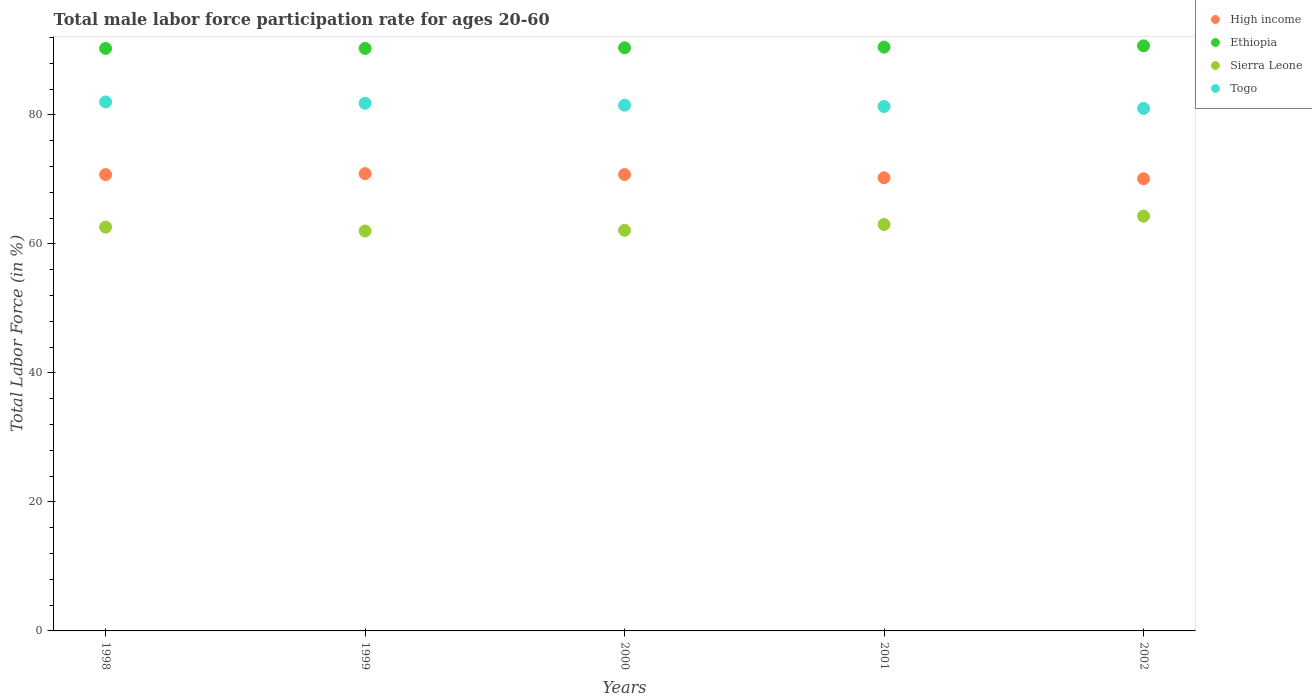How many different coloured dotlines are there?
Make the answer very short. 4. Is the number of dotlines equal to the number of legend labels?
Provide a succinct answer. Yes. What is the male labor force participation rate in Ethiopia in 1999?
Provide a short and direct response. 90.3. Across all years, what is the maximum male labor force participation rate in Sierra Leone?
Give a very brief answer. 64.3. Across all years, what is the minimum male labor force participation rate in Ethiopia?
Offer a terse response. 90.3. In which year was the male labor force participation rate in High income minimum?
Your response must be concise. 2002. What is the total male labor force participation rate in Sierra Leone in the graph?
Your answer should be very brief. 314. What is the difference between the male labor force participation rate in Ethiopia in 1999 and that in 2000?
Make the answer very short. -0.1. What is the difference between the male labor force participation rate in Sierra Leone in 1998 and the male labor force participation rate in High income in 2001?
Give a very brief answer. -7.64. What is the average male labor force participation rate in Sierra Leone per year?
Provide a short and direct response. 62.8. In the year 1999, what is the difference between the male labor force participation rate in Ethiopia and male labor force participation rate in Togo?
Keep it short and to the point. 8.5. In how many years, is the male labor force participation rate in Togo greater than 48 %?
Provide a short and direct response. 5. What is the ratio of the male labor force participation rate in Togo in 1999 to that in 2001?
Provide a succinct answer. 1.01. Is the male labor force participation rate in Togo in 1999 less than that in 2000?
Ensure brevity in your answer.  No. What is the difference between the highest and the second highest male labor force participation rate in High income?
Your answer should be very brief. 0.14. In how many years, is the male labor force participation rate in High income greater than the average male labor force participation rate in High income taken over all years?
Give a very brief answer. 3. Does the male labor force participation rate in Ethiopia monotonically increase over the years?
Ensure brevity in your answer.  No. Is the male labor force participation rate in Sierra Leone strictly less than the male labor force participation rate in Ethiopia over the years?
Offer a very short reply. Yes. How many dotlines are there?
Your answer should be very brief. 4. Does the graph contain any zero values?
Give a very brief answer. No. Does the graph contain grids?
Your answer should be very brief. No. How many legend labels are there?
Offer a terse response. 4. How are the legend labels stacked?
Offer a terse response. Vertical. What is the title of the graph?
Offer a very short reply. Total male labor force participation rate for ages 20-60. What is the label or title of the X-axis?
Ensure brevity in your answer.  Years. What is the label or title of the Y-axis?
Keep it short and to the point. Total Labor Force (in %). What is the Total Labor Force (in %) of High income in 1998?
Your response must be concise. 70.74. What is the Total Labor Force (in %) of Ethiopia in 1998?
Your response must be concise. 90.3. What is the Total Labor Force (in %) of Sierra Leone in 1998?
Provide a succinct answer. 62.6. What is the Total Labor Force (in %) of High income in 1999?
Make the answer very short. 70.88. What is the Total Labor Force (in %) of Ethiopia in 1999?
Ensure brevity in your answer.  90.3. What is the Total Labor Force (in %) of Sierra Leone in 1999?
Offer a terse response. 62. What is the Total Labor Force (in %) in Togo in 1999?
Ensure brevity in your answer.  81.8. What is the Total Labor Force (in %) in High income in 2000?
Your response must be concise. 70.75. What is the Total Labor Force (in %) in Ethiopia in 2000?
Keep it short and to the point. 90.4. What is the Total Labor Force (in %) in Sierra Leone in 2000?
Offer a terse response. 62.1. What is the Total Labor Force (in %) of Togo in 2000?
Provide a succinct answer. 81.5. What is the Total Labor Force (in %) in High income in 2001?
Keep it short and to the point. 70.24. What is the Total Labor Force (in %) in Ethiopia in 2001?
Make the answer very short. 90.5. What is the Total Labor Force (in %) of Togo in 2001?
Your answer should be very brief. 81.3. What is the Total Labor Force (in %) of High income in 2002?
Your response must be concise. 70.09. What is the Total Labor Force (in %) of Ethiopia in 2002?
Your answer should be compact. 90.7. What is the Total Labor Force (in %) of Sierra Leone in 2002?
Provide a succinct answer. 64.3. Across all years, what is the maximum Total Labor Force (in %) in High income?
Ensure brevity in your answer.  70.88. Across all years, what is the maximum Total Labor Force (in %) of Ethiopia?
Offer a very short reply. 90.7. Across all years, what is the maximum Total Labor Force (in %) of Sierra Leone?
Your answer should be compact. 64.3. Across all years, what is the maximum Total Labor Force (in %) in Togo?
Your answer should be compact. 82. Across all years, what is the minimum Total Labor Force (in %) in High income?
Provide a succinct answer. 70.09. Across all years, what is the minimum Total Labor Force (in %) in Ethiopia?
Provide a succinct answer. 90.3. Across all years, what is the minimum Total Labor Force (in %) in Sierra Leone?
Make the answer very short. 62. Across all years, what is the minimum Total Labor Force (in %) of Togo?
Ensure brevity in your answer.  81. What is the total Total Labor Force (in %) of High income in the graph?
Ensure brevity in your answer.  352.7. What is the total Total Labor Force (in %) in Ethiopia in the graph?
Your response must be concise. 452.2. What is the total Total Labor Force (in %) in Sierra Leone in the graph?
Give a very brief answer. 314. What is the total Total Labor Force (in %) in Togo in the graph?
Keep it short and to the point. 407.6. What is the difference between the Total Labor Force (in %) of High income in 1998 and that in 1999?
Ensure brevity in your answer.  -0.14. What is the difference between the Total Labor Force (in %) of Ethiopia in 1998 and that in 1999?
Give a very brief answer. 0. What is the difference between the Total Labor Force (in %) in Sierra Leone in 1998 and that in 1999?
Give a very brief answer. 0.6. What is the difference between the Total Labor Force (in %) in High income in 1998 and that in 2000?
Your response must be concise. -0.01. What is the difference between the Total Labor Force (in %) of Sierra Leone in 1998 and that in 2000?
Ensure brevity in your answer.  0.5. What is the difference between the Total Labor Force (in %) of Togo in 1998 and that in 2000?
Give a very brief answer. 0.5. What is the difference between the Total Labor Force (in %) of High income in 1998 and that in 2001?
Your response must be concise. 0.49. What is the difference between the Total Labor Force (in %) of Ethiopia in 1998 and that in 2001?
Offer a terse response. -0.2. What is the difference between the Total Labor Force (in %) in Togo in 1998 and that in 2001?
Keep it short and to the point. 0.7. What is the difference between the Total Labor Force (in %) of High income in 1998 and that in 2002?
Offer a very short reply. 0.65. What is the difference between the Total Labor Force (in %) of Sierra Leone in 1998 and that in 2002?
Provide a short and direct response. -1.7. What is the difference between the Total Labor Force (in %) of High income in 1999 and that in 2000?
Make the answer very short. 0.14. What is the difference between the Total Labor Force (in %) in Sierra Leone in 1999 and that in 2000?
Your answer should be very brief. -0.1. What is the difference between the Total Labor Force (in %) of Togo in 1999 and that in 2000?
Offer a terse response. 0.3. What is the difference between the Total Labor Force (in %) of High income in 1999 and that in 2001?
Give a very brief answer. 0.64. What is the difference between the Total Labor Force (in %) of Sierra Leone in 1999 and that in 2001?
Make the answer very short. -1. What is the difference between the Total Labor Force (in %) in High income in 1999 and that in 2002?
Offer a very short reply. 0.79. What is the difference between the Total Labor Force (in %) in Ethiopia in 1999 and that in 2002?
Give a very brief answer. -0.4. What is the difference between the Total Labor Force (in %) of Sierra Leone in 1999 and that in 2002?
Keep it short and to the point. -2.3. What is the difference between the Total Labor Force (in %) in Togo in 1999 and that in 2002?
Make the answer very short. 0.8. What is the difference between the Total Labor Force (in %) in High income in 2000 and that in 2001?
Offer a very short reply. 0.5. What is the difference between the Total Labor Force (in %) of Sierra Leone in 2000 and that in 2001?
Give a very brief answer. -0.9. What is the difference between the Total Labor Force (in %) of High income in 2000 and that in 2002?
Your answer should be compact. 0.66. What is the difference between the Total Labor Force (in %) of Ethiopia in 2000 and that in 2002?
Your answer should be very brief. -0.3. What is the difference between the Total Labor Force (in %) in Sierra Leone in 2000 and that in 2002?
Keep it short and to the point. -2.2. What is the difference between the Total Labor Force (in %) of Togo in 2000 and that in 2002?
Your answer should be very brief. 0.5. What is the difference between the Total Labor Force (in %) in High income in 2001 and that in 2002?
Your response must be concise. 0.15. What is the difference between the Total Labor Force (in %) in High income in 1998 and the Total Labor Force (in %) in Ethiopia in 1999?
Provide a short and direct response. -19.56. What is the difference between the Total Labor Force (in %) in High income in 1998 and the Total Labor Force (in %) in Sierra Leone in 1999?
Give a very brief answer. 8.74. What is the difference between the Total Labor Force (in %) of High income in 1998 and the Total Labor Force (in %) of Togo in 1999?
Offer a terse response. -11.06. What is the difference between the Total Labor Force (in %) of Ethiopia in 1998 and the Total Labor Force (in %) of Sierra Leone in 1999?
Give a very brief answer. 28.3. What is the difference between the Total Labor Force (in %) in Ethiopia in 1998 and the Total Labor Force (in %) in Togo in 1999?
Your response must be concise. 8.5. What is the difference between the Total Labor Force (in %) in Sierra Leone in 1998 and the Total Labor Force (in %) in Togo in 1999?
Give a very brief answer. -19.2. What is the difference between the Total Labor Force (in %) in High income in 1998 and the Total Labor Force (in %) in Ethiopia in 2000?
Offer a very short reply. -19.66. What is the difference between the Total Labor Force (in %) in High income in 1998 and the Total Labor Force (in %) in Sierra Leone in 2000?
Provide a succinct answer. 8.64. What is the difference between the Total Labor Force (in %) in High income in 1998 and the Total Labor Force (in %) in Togo in 2000?
Make the answer very short. -10.76. What is the difference between the Total Labor Force (in %) of Ethiopia in 1998 and the Total Labor Force (in %) of Sierra Leone in 2000?
Make the answer very short. 28.2. What is the difference between the Total Labor Force (in %) of Sierra Leone in 1998 and the Total Labor Force (in %) of Togo in 2000?
Your answer should be compact. -18.9. What is the difference between the Total Labor Force (in %) in High income in 1998 and the Total Labor Force (in %) in Ethiopia in 2001?
Offer a terse response. -19.76. What is the difference between the Total Labor Force (in %) of High income in 1998 and the Total Labor Force (in %) of Sierra Leone in 2001?
Make the answer very short. 7.74. What is the difference between the Total Labor Force (in %) in High income in 1998 and the Total Labor Force (in %) in Togo in 2001?
Provide a succinct answer. -10.56. What is the difference between the Total Labor Force (in %) of Ethiopia in 1998 and the Total Labor Force (in %) of Sierra Leone in 2001?
Offer a very short reply. 27.3. What is the difference between the Total Labor Force (in %) of Ethiopia in 1998 and the Total Labor Force (in %) of Togo in 2001?
Make the answer very short. 9. What is the difference between the Total Labor Force (in %) in Sierra Leone in 1998 and the Total Labor Force (in %) in Togo in 2001?
Your response must be concise. -18.7. What is the difference between the Total Labor Force (in %) in High income in 1998 and the Total Labor Force (in %) in Ethiopia in 2002?
Provide a succinct answer. -19.96. What is the difference between the Total Labor Force (in %) of High income in 1998 and the Total Labor Force (in %) of Sierra Leone in 2002?
Provide a succinct answer. 6.44. What is the difference between the Total Labor Force (in %) of High income in 1998 and the Total Labor Force (in %) of Togo in 2002?
Give a very brief answer. -10.26. What is the difference between the Total Labor Force (in %) in Ethiopia in 1998 and the Total Labor Force (in %) in Togo in 2002?
Give a very brief answer. 9.3. What is the difference between the Total Labor Force (in %) in Sierra Leone in 1998 and the Total Labor Force (in %) in Togo in 2002?
Offer a terse response. -18.4. What is the difference between the Total Labor Force (in %) in High income in 1999 and the Total Labor Force (in %) in Ethiopia in 2000?
Ensure brevity in your answer.  -19.52. What is the difference between the Total Labor Force (in %) of High income in 1999 and the Total Labor Force (in %) of Sierra Leone in 2000?
Provide a succinct answer. 8.78. What is the difference between the Total Labor Force (in %) in High income in 1999 and the Total Labor Force (in %) in Togo in 2000?
Keep it short and to the point. -10.62. What is the difference between the Total Labor Force (in %) of Ethiopia in 1999 and the Total Labor Force (in %) of Sierra Leone in 2000?
Provide a short and direct response. 28.2. What is the difference between the Total Labor Force (in %) of Sierra Leone in 1999 and the Total Labor Force (in %) of Togo in 2000?
Provide a short and direct response. -19.5. What is the difference between the Total Labor Force (in %) of High income in 1999 and the Total Labor Force (in %) of Ethiopia in 2001?
Provide a short and direct response. -19.62. What is the difference between the Total Labor Force (in %) of High income in 1999 and the Total Labor Force (in %) of Sierra Leone in 2001?
Your answer should be compact. 7.88. What is the difference between the Total Labor Force (in %) in High income in 1999 and the Total Labor Force (in %) in Togo in 2001?
Offer a very short reply. -10.42. What is the difference between the Total Labor Force (in %) of Ethiopia in 1999 and the Total Labor Force (in %) of Sierra Leone in 2001?
Give a very brief answer. 27.3. What is the difference between the Total Labor Force (in %) of Ethiopia in 1999 and the Total Labor Force (in %) of Togo in 2001?
Provide a succinct answer. 9. What is the difference between the Total Labor Force (in %) in Sierra Leone in 1999 and the Total Labor Force (in %) in Togo in 2001?
Offer a terse response. -19.3. What is the difference between the Total Labor Force (in %) of High income in 1999 and the Total Labor Force (in %) of Ethiopia in 2002?
Your answer should be very brief. -19.82. What is the difference between the Total Labor Force (in %) of High income in 1999 and the Total Labor Force (in %) of Sierra Leone in 2002?
Offer a terse response. 6.58. What is the difference between the Total Labor Force (in %) of High income in 1999 and the Total Labor Force (in %) of Togo in 2002?
Make the answer very short. -10.12. What is the difference between the Total Labor Force (in %) of Ethiopia in 1999 and the Total Labor Force (in %) of Sierra Leone in 2002?
Give a very brief answer. 26. What is the difference between the Total Labor Force (in %) of Ethiopia in 1999 and the Total Labor Force (in %) of Togo in 2002?
Your answer should be compact. 9.3. What is the difference between the Total Labor Force (in %) of Sierra Leone in 1999 and the Total Labor Force (in %) of Togo in 2002?
Give a very brief answer. -19. What is the difference between the Total Labor Force (in %) of High income in 2000 and the Total Labor Force (in %) of Ethiopia in 2001?
Your answer should be very brief. -19.75. What is the difference between the Total Labor Force (in %) of High income in 2000 and the Total Labor Force (in %) of Sierra Leone in 2001?
Ensure brevity in your answer.  7.75. What is the difference between the Total Labor Force (in %) of High income in 2000 and the Total Labor Force (in %) of Togo in 2001?
Keep it short and to the point. -10.55. What is the difference between the Total Labor Force (in %) of Ethiopia in 2000 and the Total Labor Force (in %) of Sierra Leone in 2001?
Ensure brevity in your answer.  27.4. What is the difference between the Total Labor Force (in %) of Ethiopia in 2000 and the Total Labor Force (in %) of Togo in 2001?
Ensure brevity in your answer.  9.1. What is the difference between the Total Labor Force (in %) of Sierra Leone in 2000 and the Total Labor Force (in %) of Togo in 2001?
Your answer should be very brief. -19.2. What is the difference between the Total Labor Force (in %) in High income in 2000 and the Total Labor Force (in %) in Ethiopia in 2002?
Provide a short and direct response. -19.95. What is the difference between the Total Labor Force (in %) in High income in 2000 and the Total Labor Force (in %) in Sierra Leone in 2002?
Keep it short and to the point. 6.45. What is the difference between the Total Labor Force (in %) of High income in 2000 and the Total Labor Force (in %) of Togo in 2002?
Ensure brevity in your answer.  -10.25. What is the difference between the Total Labor Force (in %) of Ethiopia in 2000 and the Total Labor Force (in %) of Sierra Leone in 2002?
Give a very brief answer. 26.1. What is the difference between the Total Labor Force (in %) in Ethiopia in 2000 and the Total Labor Force (in %) in Togo in 2002?
Provide a succinct answer. 9.4. What is the difference between the Total Labor Force (in %) of Sierra Leone in 2000 and the Total Labor Force (in %) of Togo in 2002?
Your answer should be very brief. -18.9. What is the difference between the Total Labor Force (in %) of High income in 2001 and the Total Labor Force (in %) of Ethiopia in 2002?
Your answer should be compact. -20.46. What is the difference between the Total Labor Force (in %) in High income in 2001 and the Total Labor Force (in %) in Sierra Leone in 2002?
Keep it short and to the point. 5.94. What is the difference between the Total Labor Force (in %) in High income in 2001 and the Total Labor Force (in %) in Togo in 2002?
Offer a terse response. -10.76. What is the difference between the Total Labor Force (in %) in Ethiopia in 2001 and the Total Labor Force (in %) in Sierra Leone in 2002?
Give a very brief answer. 26.2. What is the difference between the Total Labor Force (in %) of Sierra Leone in 2001 and the Total Labor Force (in %) of Togo in 2002?
Your answer should be very brief. -18. What is the average Total Labor Force (in %) in High income per year?
Provide a short and direct response. 70.54. What is the average Total Labor Force (in %) of Ethiopia per year?
Your answer should be very brief. 90.44. What is the average Total Labor Force (in %) of Sierra Leone per year?
Offer a very short reply. 62.8. What is the average Total Labor Force (in %) in Togo per year?
Offer a very short reply. 81.52. In the year 1998, what is the difference between the Total Labor Force (in %) in High income and Total Labor Force (in %) in Ethiopia?
Make the answer very short. -19.56. In the year 1998, what is the difference between the Total Labor Force (in %) of High income and Total Labor Force (in %) of Sierra Leone?
Provide a short and direct response. 8.14. In the year 1998, what is the difference between the Total Labor Force (in %) of High income and Total Labor Force (in %) of Togo?
Offer a very short reply. -11.26. In the year 1998, what is the difference between the Total Labor Force (in %) of Ethiopia and Total Labor Force (in %) of Sierra Leone?
Your answer should be very brief. 27.7. In the year 1998, what is the difference between the Total Labor Force (in %) of Sierra Leone and Total Labor Force (in %) of Togo?
Provide a short and direct response. -19.4. In the year 1999, what is the difference between the Total Labor Force (in %) of High income and Total Labor Force (in %) of Ethiopia?
Provide a succinct answer. -19.42. In the year 1999, what is the difference between the Total Labor Force (in %) of High income and Total Labor Force (in %) of Sierra Leone?
Your response must be concise. 8.88. In the year 1999, what is the difference between the Total Labor Force (in %) in High income and Total Labor Force (in %) in Togo?
Make the answer very short. -10.92. In the year 1999, what is the difference between the Total Labor Force (in %) of Ethiopia and Total Labor Force (in %) of Sierra Leone?
Your answer should be compact. 28.3. In the year 1999, what is the difference between the Total Labor Force (in %) of Ethiopia and Total Labor Force (in %) of Togo?
Ensure brevity in your answer.  8.5. In the year 1999, what is the difference between the Total Labor Force (in %) of Sierra Leone and Total Labor Force (in %) of Togo?
Provide a short and direct response. -19.8. In the year 2000, what is the difference between the Total Labor Force (in %) of High income and Total Labor Force (in %) of Ethiopia?
Offer a terse response. -19.65. In the year 2000, what is the difference between the Total Labor Force (in %) in High income and Total Labor Force (in %) in Sierra Leone?
Keep it short and to the point. 8.65. In the year 2000, what is the difference between the Total Labor Force (in %) in High income and Total Labor Force (in %) in Togo?
Your answer should be compact. -10.75. In the year 2000, what is the difference between the Total Labor Force (in %) of Ethiopia and Total Labor Force (in %) of Sierra Leone?
Your answer should be compact. 28.3. In the year 2000, what is the difference between the Total Labor Force (in %) of Ethiopia and Total Labor Force (in %) of Togo?
Give a very brief answer. 8.9. In the year 2000, what is the difference between the Total Labor Force (in %) in Sierra Leone and Total Labor Force (in %) in Togo?
Make the answer very short. -19.4. In the year 2001, what is the difference between the Total Labor Force (in %) in High income and Total Labor Force (in %) in Ethiopia?
Keep it short and to the point. -20.26. In the year 2001, what is the difference between the Total Labor Force (in %) in High income and Total Labor Force (in %) in Sierra Leone?
Your response must be concise. 7.24. In the year 2001, what is the difference between the Total Labor Force (in %) of High income and Total Labor Force (in %) of Togo?
Provide a succinct answer. -11.06. In the year 2001, what is the difference between the Total Labor Force (in %) in Ethiopia and Total Labor Force (in %) in Sierra Leone?
Keep it short and to the point. 27.5. In the year 2001, what is the difference between the Total Labor Force (in %) of Ethiopia and Total Labor Force (in %) of Togo?
Offer a very short reply. 9.2. In the year 2001, what is the difference between the Total Labor Force (in %) in Sierra Leone and Total Labor Force (in %) in Togo?
Make the answer very short. -18.3. In the year 2002, what is the difference between the Total Labor Force (in %) of High income and Total Labor Force (in %) of Ethiopia?
Your answer should be very brief. -20.61. In the year 2002, what is the difference between the Total Labor Force (in %) in High income and Total Labor Force (in %) in Sierra Leone?
Give a very brief answer. 5.79. In the year 2002, what is the difference between the Total Labor Force (in %) in High income and Total Labor Force (in %) in Togo?
Make the answer very short. -10.91. In the year 2002, what is the difference between the Total Labor Force (in %) in Ethiopia and Total Labor Force (in %) in Sierra Leone?
Provide a short and direct response. 26.4. In the year 2002, what is the difference between the Total Labor Force (in %) of Ethiopia and Total Labor Force (in %) of Togo?
Give a very brief answer. 9.7. In the year 2002, what is the difference between the Total Labor Force (in %) of Sierra Leone and Total Labor Force (in %) of Togo?
Offer a terse response. -16.7. What is the ratio of the Total Labor Force (in %) of High income in 1998 to that in 1999?
Your answer should be compact. 1. What is the ratio of the Total Labor Force (in %) in Sierra Leone in 1998 to that in 1999?
Your answer should be very brief. 1.01. What is the ratio of the Total Labor Force (in %) of Togo in 1998 to that in 1999?
Ensure brevity in your answer.  1. What is the ratio of the Total Labor Force (in %) of High income in 1998 to that in 2000?
Offer a very short reply. 1. What is the ratio of the Total Labor Force (in %) in Sierra Leone in 1998 to that in 2000?
Your answer should be compact. 1.01. What is the ratio of the Total Labor Force (in %) in Togo in 1998 to that in 2000?
Your answer should be very brief. 1.01. What is the ratio of the Total Labor Force (in %) of Ethiopia in 1998 to that in 2001?
Offer a very short reply. 1. What is the ratio of the Total Labor Force (in %) of Togo in 1998 to that in 2001?
Make the answer very short. 1.01. What is the ratio of the Total Labor Force (in %) of High income in 1998 to that in 2002?
Your answer should be very brief. 1.01. What is the ratio of the Total Labor Force (in %) in Sierra Leone in 1998 to that in 2002?
Give a very brief answer. 0.97. What is the ratio of the Total Labor Force (in %) in Togo in 1998 to that in 2002?
Offer a very short reply. 1.01. What is the ratio of the Total Labor Force (in %) of High income in 1999 to that in 2000?
Give a very brief answer. 1. What is the ratio of the Total Labor Force (in %) of Ethiopia in 1999 to that in 2000?
Keep it short and to the point. 1. What is the ratio of the Total Labor Force (in %) in Sierra Leone in 1999 to that in 2000?
Keep it short and to the point. 1. What is the ratio of the Total Labor Force (in %) in Togo in 1999 to that in 2000?
Provide a short and direct response. 1. What is the ratio of the Total Labor Force (in %) of High income in 1999 to that in 2001?
Provide a short and direct response. 1.01. What is the ratio of the Total Labor Force (in %) in Sierra Leone in 1999 to that in 2001?
Offer a very short reply. 0.98. What is the ratio of the Total Labor Force (in %) of Togo in 1999 to that in 2001?
Give a very brief answer. 1.01. What is the ratio of the Total Labor Force (in %) in High income in 1999 to that in 2002?
Provide a short and direct response. 1.01. What is the ratio of the Total Labor Force (in %) of Ethiopia in 1999 to that in 2002?
Keep it short and to the point. 1. What is the ratio of the Total Labor Force (in %) of Sierra Leone in 1999 to that in 2002?
Give a very brief answer. 0.96. What is the ratio of the Total Labor Force (in %) in Togo in 1999 to that in 2002?
Give a very brief answer. 1.01. What is the ratio of the Total Labor Force (in %) of High income in 2000 to that in 2001?
Your response must be concise. 1.01. What is the ratio of the Total Labor Force (in %) in Ethiopia in 2000 to that in 2001?
Your response must be concise. 1. What is the ratio of the Total Labor Force (in %) in Sierra Leone in 2000 to that in 2001?
Keep it short and to the point. 0.99. What is the ratio of the Total Labor Force (in %) in High income in 2000 to that in 2002?
Offer a terse response. 1.01. What is the ratio of the Total Labor Force (in %) of Ethiopia in 2000 to that in 2002?
Offer a very short reply. 1. What is the ratio of the Total Labor Force (in %) in Sierra Leone in 2000 to that in 2002?
Your response must be concise. 0.97. What is the ratio of the Total Labor Force (in %) in High income in 2001 to that in 2002?
Your response must be concise. 1. What is the ratio of the Total Labor Force (in %) in Sierra Leone in 2001 to that in 2002?
Provide a short and direct response. 0.98. What is the difference between the highest and the second highest Total Labor Force (in %) in High income?
Your response must be concise. 0.14. What is the difference between the highest and the second highest Total Labor Force (in %) in Sierra Leone?
Keep it short and to the point. 1.3. What is the difference between the highest and the second highest Total Labor Force (in %) of Togo?
Provide a succinct answer. 0.2. What is the difference between the highest and the lowest Total Labor Force (in %) of High income?
Give a very brief answer. 0.79. What is the difference between the highest and the lowest Total Labor Force (in %) of Ethiopia?
Provide a short and direct response. 0.4. What is the difference between the highest and the lowest Total Labor Force (in %) in Sierra Leone?
Provide a succinct answer. 2.3. 